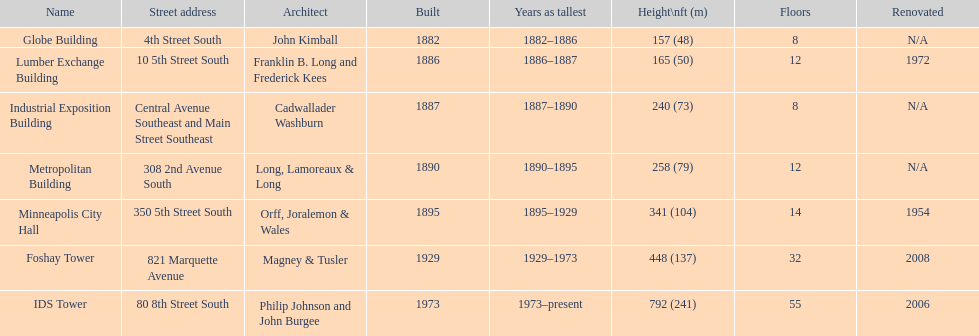How many of the listed buildings have a height greater than 200 feet? 5. 